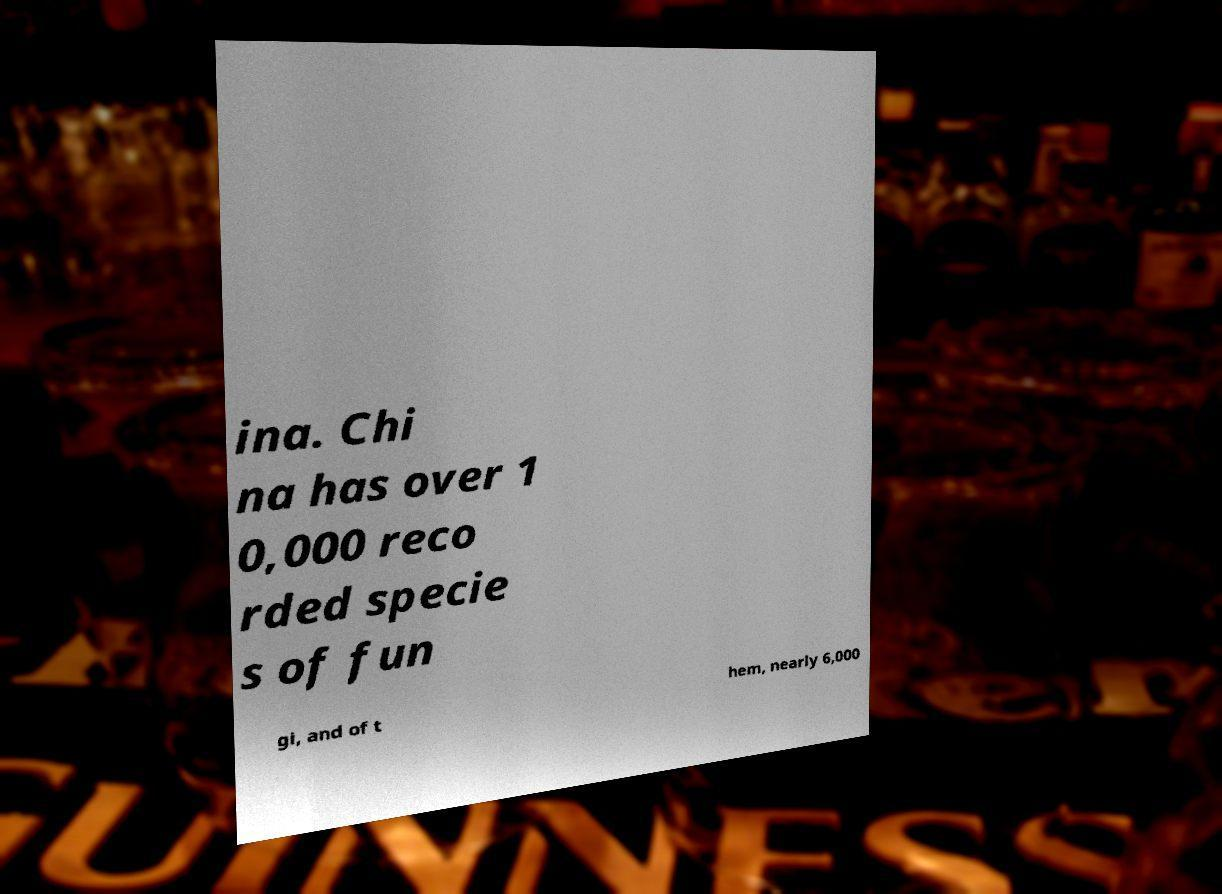Could you assist in decoding the text presented in this image and type it out clearly? ina. Chi na has over 1 0,000 reco rded specie s of fun gi, and of t hem, nearly 6,000 